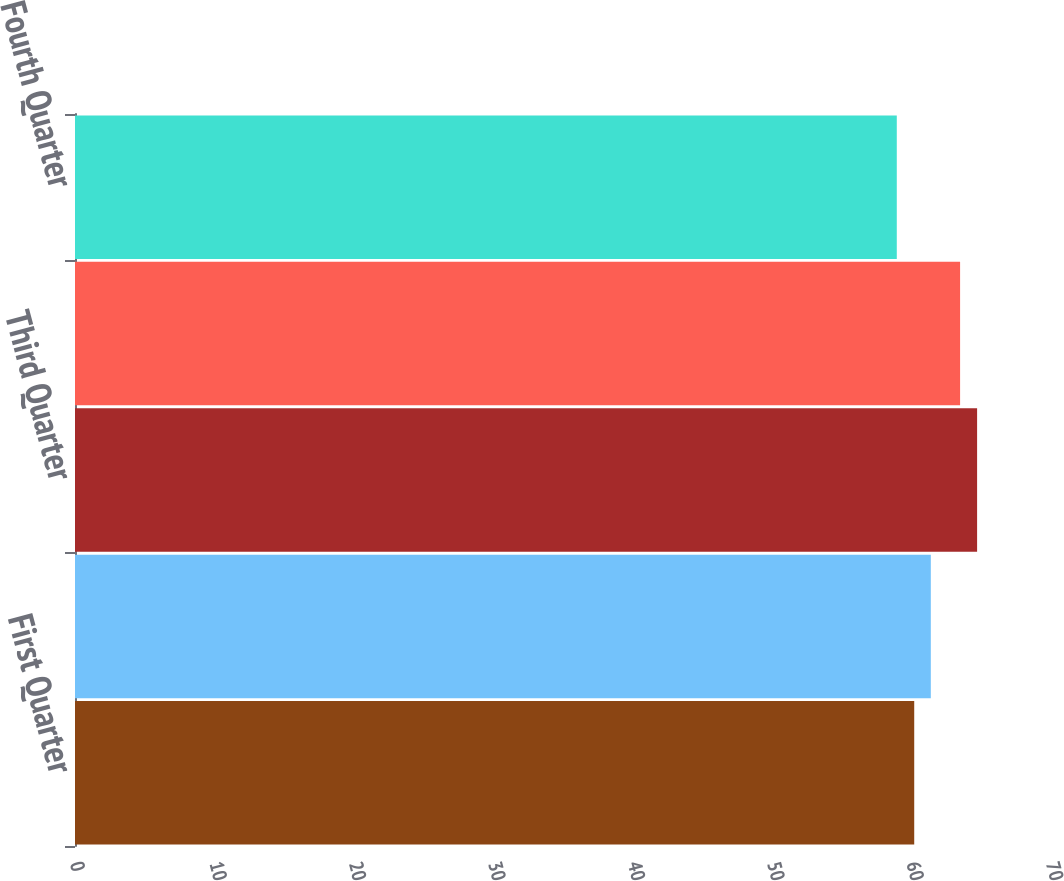<chart> <loc_0><loc_0><loc_500><loc_500><bar_chart><fcel>First Quarter<fcel>Second Quarter<fcel>Third Quarter<fcel>Fourth Quarter (a)<fcel>Fourth Quarter<nl><fcel>60.19<fcel>61.38<fcel>64.7<fcel>63.48<fcel>58.94<nl></chart> 